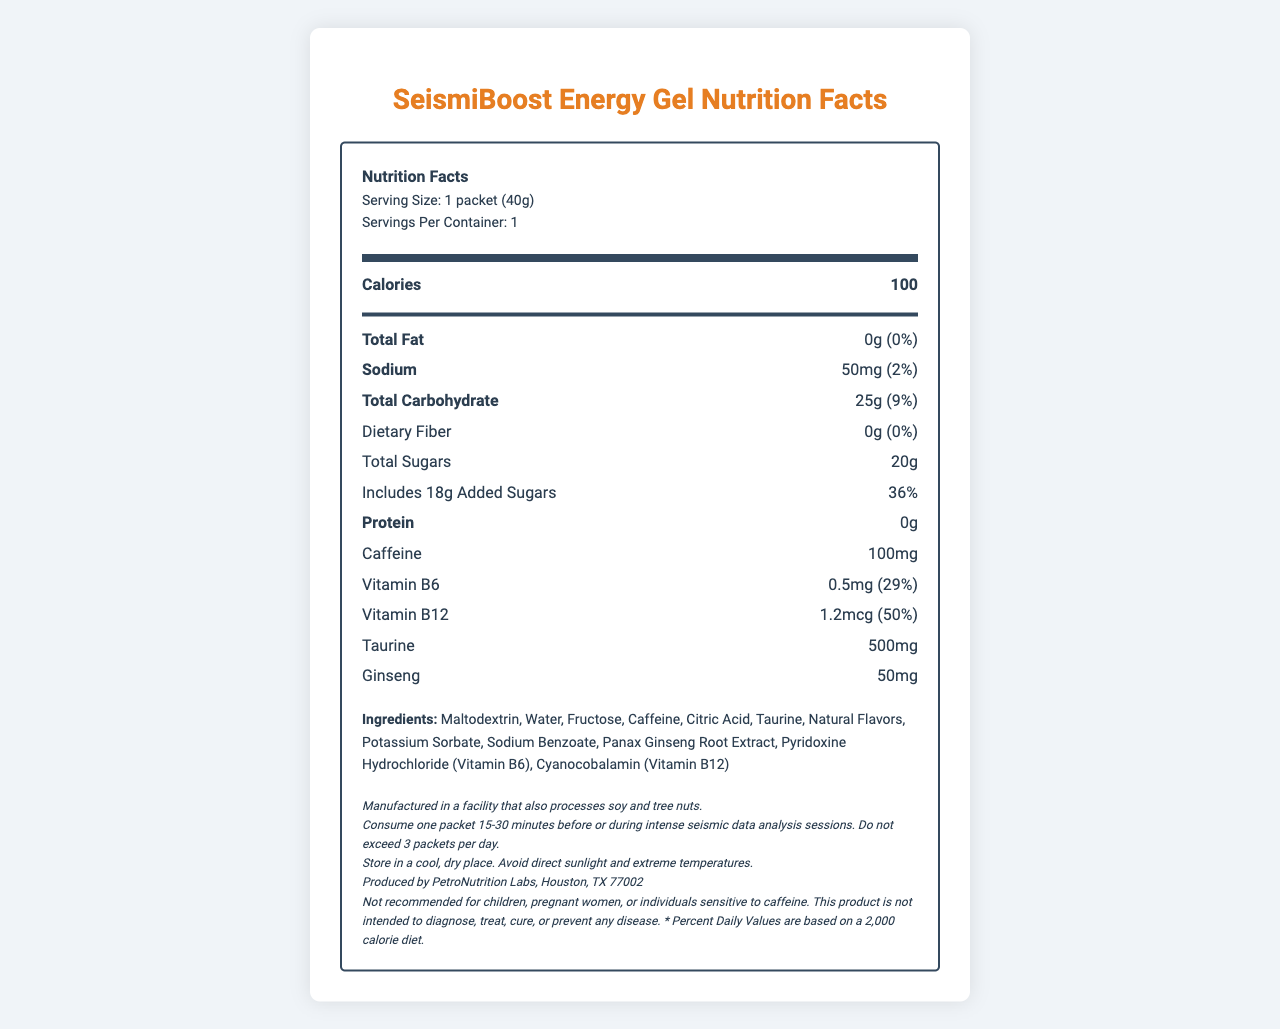what is the serving size for SeismiBoost Energy Gel? The serving size is clearly listed under the header "Serving Size" in the document.
Answer: 1 packet (40g) how many calories does one serving of SeismiBoost Energy Gel contain? The caloric content is displayed under the "Calories" section.
Answer: 100 what is the daily value percentage of Sodium in one packet of SeismiBoost Energy Gel? The daily value percentage for Sodium is shown next to its amount, which is 50mg.
Answer: 2% how many grams of added sugars are there in SeismiBoost Energy Gel? The amount of added sugars is specified under "Includes Added Sugars" in the document.
Answer: 18g what is the amount of Vitamin B12 in SeismiBoost Energy Gel? The Vitamin B12 content is listed with its respective amount and daily value percentage.
Answer: 1.2mcg how much taurine is in SeismiBoost Energy Gel? The amount of taurine is mentioned in its respective nutrient section.
Answer: 500mg which of the following ingredients is not listed in SeismiBoost Energy Gel? A. Fructose B. Sucralose C. Maltodextrin D. Panax Ginseng Root Extract Sucralose is not listed among the ingredients in the document.
Answer: B. Sucralose what is the recommended consumption direction for SeismiBoost Energy Gel? A. Before meals B. During low-intensity tasks C. Before or during intense seismic data analysis sessions D. Before bedtime The directions specify to consume one packet 15-30 minutes before or during intense seismic data analysis.
Answer: C. Before or during intense seismic data analysis sessions is SeismiBoost Energy Gel recommended for children? The disclaimer section clearly states that it is not recommended for children.
Answer: No is SeismiBoost Energy Gel suitable for people with soy allergies? The allergen information states it is manufactured in a facility that processes soy, so it may contain traces of soy, but it does not specify if it is suitable for people with soy allergies.
Answer: Not enough information summarize the main nutritional and ingredient information of SeismiBoost Energy Gel. This summary includes all essential nutritional facts, ingredients, and consumption recommendations as outlined in the document.
Answer: SeismiBoost Energy Gel contains 100 calories per serving, with 0g of fat, 50mg of sodium, 25g of carbohydrates including 18g of added sugars, and 0g of protein. It provides 100mg of caffeine, 0.5mg of Vitamin B6, 1.2mcg of Vitamin B12, 500mg of taurine, and 50mg of ginseng. The main ingredients include maltodextrin, water, fructose, caffeine, citric acid, and more. It is recommended to be consumed before or during intense seismic data analysis sessions, with a limitation of 3 packets per day. The product is manufactured in a facility that also processes soy and tree nuts, and it is not recommended for children or those sensitive to caffeine. 